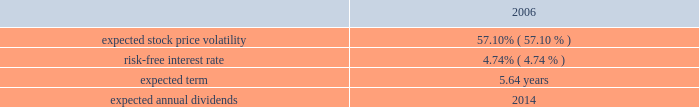Vertex pharmaceuticals incorporated notes to consolidated financial statements ( continued ) d .
Stock-based compensation ( continued ) the company uses the black-scholes valuation model to estimate the fair value of stock options at the grant date .
The black-scholes valuation model uses the option exercise price as well as estimates and assumptions related to the expected price volatility of the company 2019s stock , the period during which the options will be outstanding , the rate of return on risk-free investments , and the expected dividend yield for the company 2019s stock to estimate the fair value of a stock option on the grant date .
The company validates its estimates and assumptions through consultations with independent third parties having relevant expertise .
The fair value of each option granted under the stock and option plans during 2006 was estimated on the date of grant using the black- scholes option pricing model with the following weighted average assumptions : the weighted-average valuation assumptions were determined as follows : 2022 expected stock price volatility : in 2006 , the company changed its method of estimating expected volatility from relying exclusively on historical volatility to relying exclusively on implied volatility .
Options to purchase the company 2019s stock with remaining terms of greater than one year are regularly traded in the market .
Expected stock price volatility is calculated using the trailing one month average of daily implied volatilities prior to grant date .
2022 risk-free interest rate : the company bases the risk-free interest rate on the interest rate payable on u.s .
Treasury securities in effect at the time of grant for a period that is commensurate with the assumed expected option term .
2022 expected term of options : the expected term of options represents the period of time options are expected to be outstanding .
The company uses historical data to estimate employee exercise and post-vest termination behavior .
The company believes that all groups of employees exhibit similar exercise and post-vest termination behavior and therefore does not stratify employees into multiple groups in determining the expected term of options .
2022 expected annual dividends : the estimate for annual dividends is $ 0.00 , because the company has not historically paid , and does not intend for the foreseeable future to pay , a dividend .
Expected stock price volatility 57.10 % (  % ) risk-free interest rate 4.74 % (  % ) expected term 5.64 years .

In 2006 what was the ratio expected stock price volatility to risk-free interest rate? 
Computations: (57.10 / 4.74)
Answer: 12.04641. 